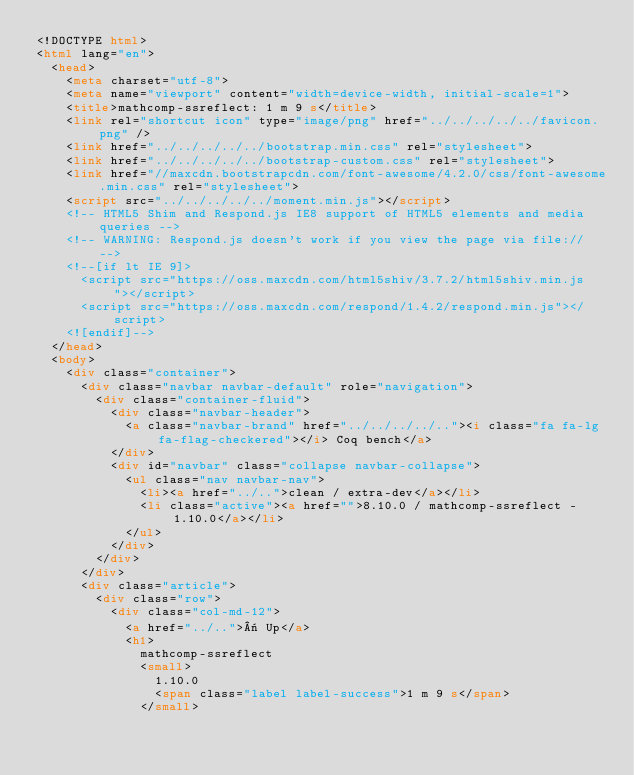<code> <loc_0><loc_0><loc_500><loc_500><_HTML_><!DOCTYPE html>
<html lang="en">
  <head>
    <meta charset="utf-8">
    <meta name="viewport" content="width=device-width, initial-scale=1">
    <title>mathcomp-ssreflect: 1 m 9 s</title>
    <link rel="shortcut icon" type="image/png" href="../../../../../favicon.png" />
    <link href="../../../../../bootstrap.min.css" rel="stylesheet">
    <link href="../../../../../bootstrap-custom.css" rel="stylesheet">
    <link href="//maxcdn.bootstrapcdn.com/font-awesome/4.2.0/css/font-awesome.min.css" rel="stylesheet">
    <script src="../../../../../moment.min.js"></script>
    <!-- HTML5 Shim and Respond.js IE8 support of HTML5 elements and media queries -->
    <!-- WARNING: Respond.js doesn't work if you view the page via file:// -->
    <!--[if lt IE 9]>
      <script src="https://oss.maxcdn.com/html5shiv/3.7.2/html5shiv.min.js"></script>
      <script src="https://oss.maxcdn.com/respond/1.4.2/respond.min.js"></script>
    <![endif]-->
  </head>
  <body>
    <div class="container">
      <div class="navbar navbar-default" role="navigation">
        <div class="container-fluid">
          <div class="navbar-header">
            <a class="navbar-brand" href="../../../../.."><i class="fa fa-lg fa-flag-checkered"></i> Coq bench</a>
          </div>
          <div id="navbar" class="collapse navbar-collapse">
            <ul class="nav navbar-nav">
              <li><a href="../..">clean / extra-dev</a></li>
              <li class="active"><a href="">8.10.0 / mathcomp-ssreflect - 1.10.0</a></li>
            </ul>
          </div>
        </div>
      </div>
      <div class="article">
        <div class="row">
          <div class="col-md-12">
            <a href="../..">« Up</a>
            <h1>
              mathcomp-ssreflect
              <small>
                1.10.0
                <span class="label label-success">1 m 9 s</span>
              </small></code> 